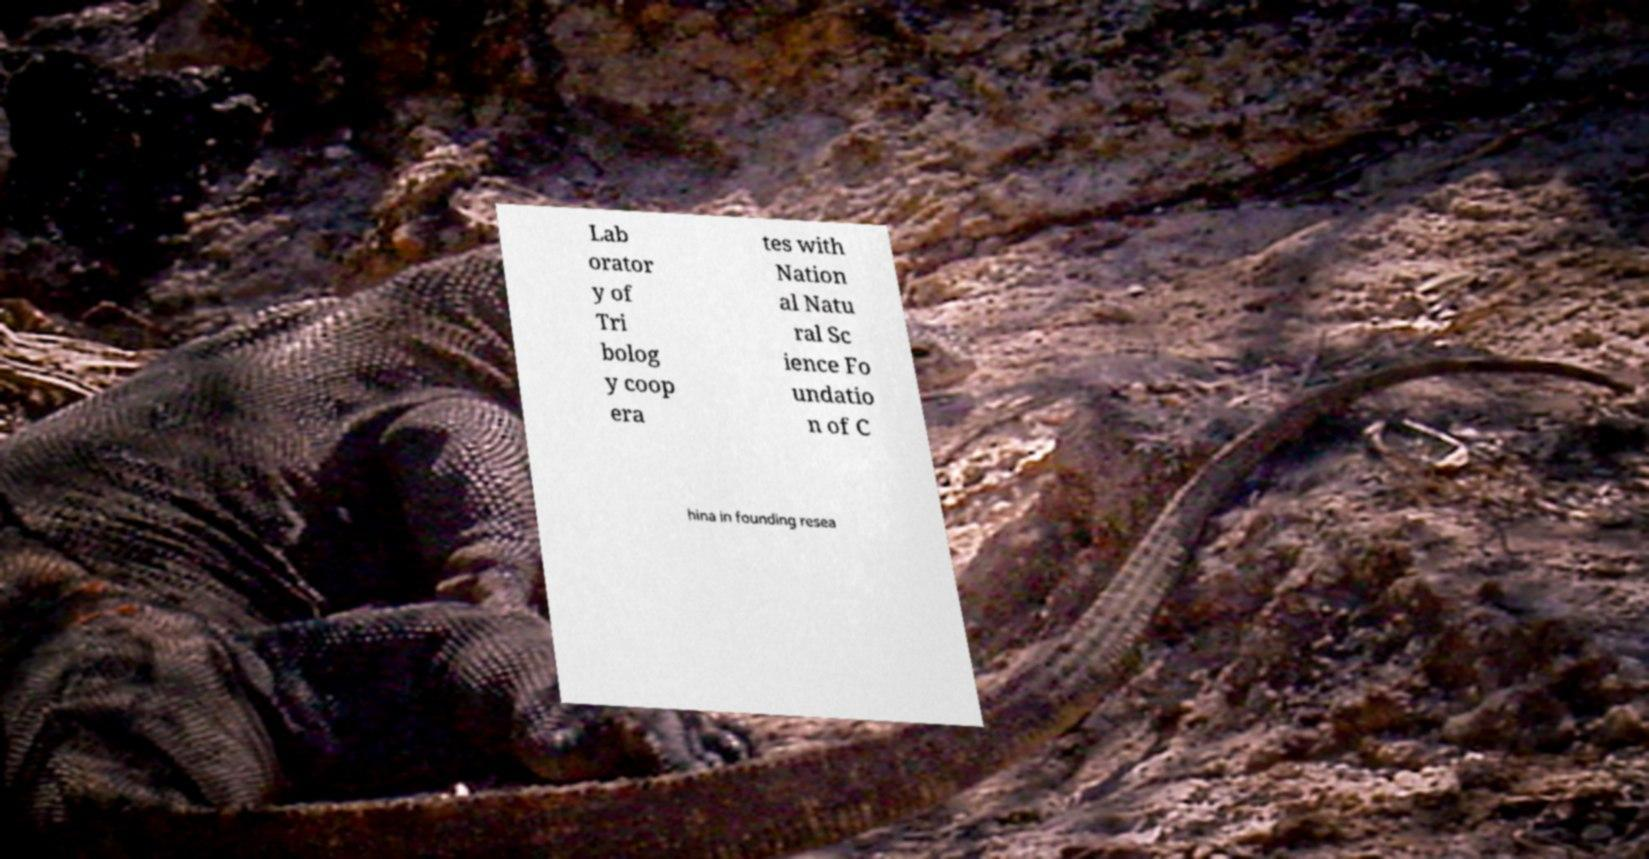There's text embedded in this image that I need extracted. Can you transcribe it verbatim? Lab orator y of Tri bolog y coop era tes with Nation al Natu ral Sc ience Fo undatio n of C hina in founding resea 